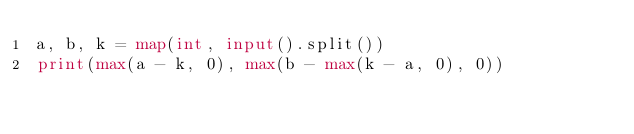<code> <loc_0><loc_0><loc_500><loc_500><_Python_>a, b, k = map(int, input().split())
print(max(a - k, 0), max(b - max(k - a, 0), 0))
</code> 